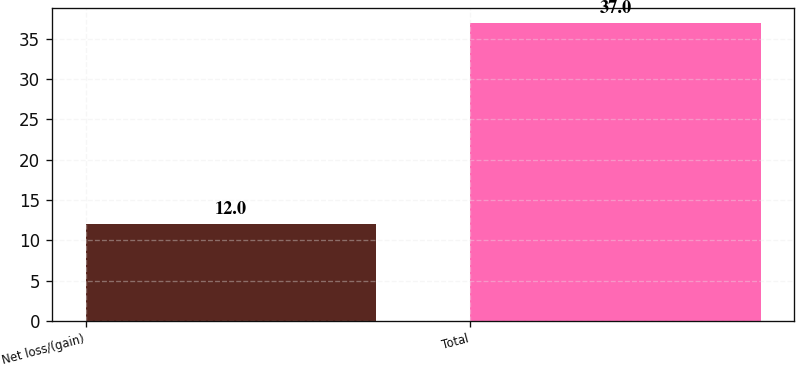Convert chart to OTSL. <chart><loc_0><loc_0><loc_500><loc_500><bar_chart><fcel>Net loss/(gain)<fcel>Total<nl><fcel>12<fcel>37<nl></chart> 